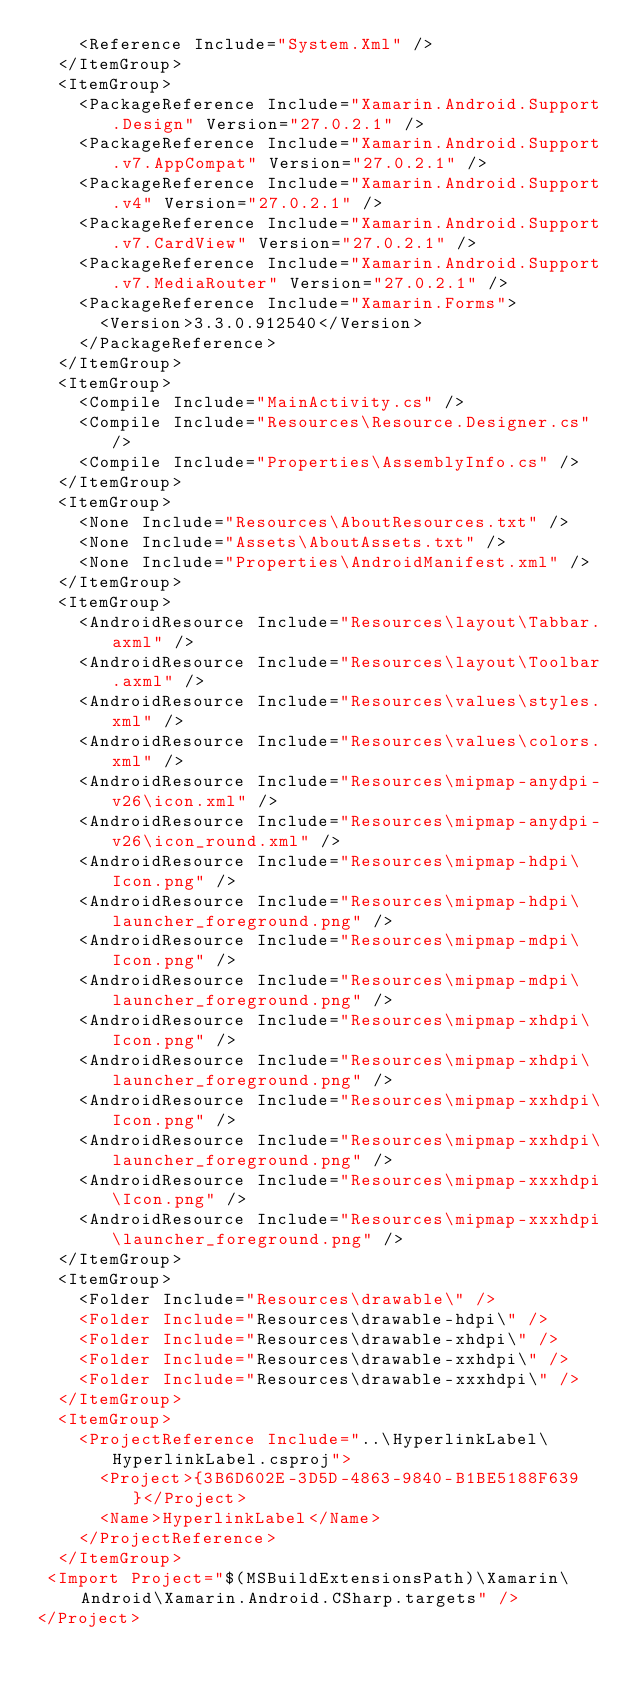<code> <loc_0><loc_0><loc_500><loc_500><_XML_>    <Reference Include="System.Xml" />
  </ItemGroup>
  <ItemGroup>
    <PackageReference Include="Xamarin.Android.Support.Design" Version="27.0.2.1" />
    <PackageReference Include="Xamarin.Android.Support.v7.AppCompat" Version="27.0.2.1" />
    <PackageReference Include="Xamarin.Android.Support.v4" Version="27.0.2.1" />
    <PackageReference Include="Xamarin.Android.Support.v7.CardView" Version="27.0.2.1" />
    <PackageReference Include="Xamarin.Android.Support.v7.MediaRouter" Version="27.0.2.1" />
    <PackageReference Include="Xamarin.Forms">
      <Version>3.3.0.912540</Version>
    </PackageReference>
  </ItemGroup>
  <ItemGroup>
    <Compile Include="MainActivity.cs" />
    <Compile Include="Resources\Resource.Designer.cs" />
    <Compile Include="Properties\AssemblyInfo.cs" />
  </ItemGroup>
  <ItemGroup>
    <None Include="Resources\AboutResources.txt" />
    <None Include="Assets\AboutAssets.txt" />
    <None Include="Properties\AndroidManifest.xml" />
  </ItemGroup>
  <ItemGroup>
    <AndroidResource Include="Resources\layout\Tabbar.axml" />
    <AndroidResource Include="Resources\layout\Toolbar.axml" />
    <AndroidResource Include="Resources\values\styles.xml" />
    <AndroidResource Include="Resources\values\colors.xml" />
    <AndroidResource Include="Resources\mipmap-anydpi-v26\icon.xml" />
    <AndroidResource Include="Resources\mipmap-anydpi-v26\icon_round.xml" />
    <AndroidResource Include="Resources\mipmap-hdpi\Icon.png" />
    <AndroidResource Include="Resources\mipmap-hdpi\launcher_foreground.png" />
    <AndroidResource Include="Resources\mipmap-mdpi\Icon.png" />
    <AndroidResource Include="Resources\mipmap-mdpi\launcher_foreground.png" />
    <AndroidResource Include="Resources\mipmap-xhdpi\Icon.png" />
    <AndroidResource Include="Resources\mipmap-xhdpi\launcher_foreground.png" />
    <AndroidResource Include="Resources\mipmap-xxhdpi\Icon.png" />
    <AndroidResource Include="Resources\mipmap-xxhdpi\launcher_foreground.png" />
    <AndroidResource Include="Resources\mipmap-xxxhdpi\Icon.png" />
    <AndroidResource Include="Resources\mipmap-xxxhdpi\launcher_foreground.png" />
  </ItemGroup>
  <ItemGroup>
    <Folder Include="Resources\drawable\" />
    <Folder Include="Resources\drawable-hdpi\" />
    <Folder Include="Resources\drawable-xhdpi\" />
    <Folder Include="Resources\drawable-xxhdpi\" />
    <Folder Include="Resources\drawable-xxxhdpi\" />
  </ItemGroup>
  <ItemGroup>
    <ProjectReference Include="..\HyperlinkLabel\HyperlinkLabel.csproj">
      <Project>{3B6D602E-3D5D-4863-9840-B1BE5188F639}</Project>
      <Name>HyperlinkLabel</Name>
    </ProjectReference>
  </ItemGroup>
 <Import Project="$(MSBuildExtensionsPath)\Xamarin\Android\Xamarin.Android.CSharp.targets" />
</Project>
</code> 